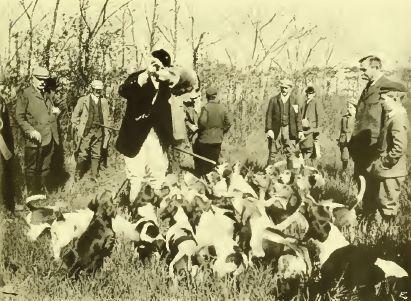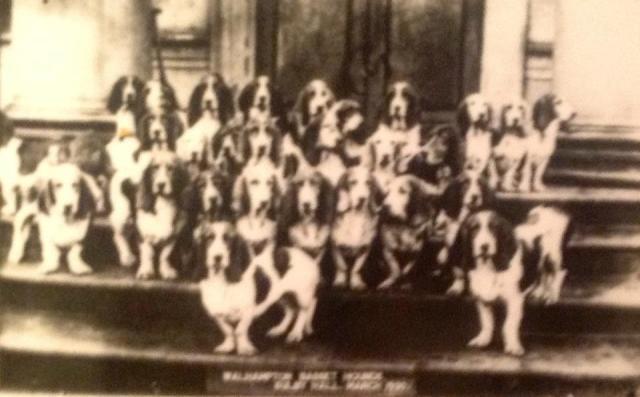The first image is the image on the left, the second image is the image on the right. Examine the images to the left and right. Is the description "There are no more than eight dogs in the right image." accurate? Answer yes or no. No. The first image is the image on the left, the second image is the image on the right. For the images shown, is this caption "Every single image contains more than one dog." true? Answer yes or no. Yes. 